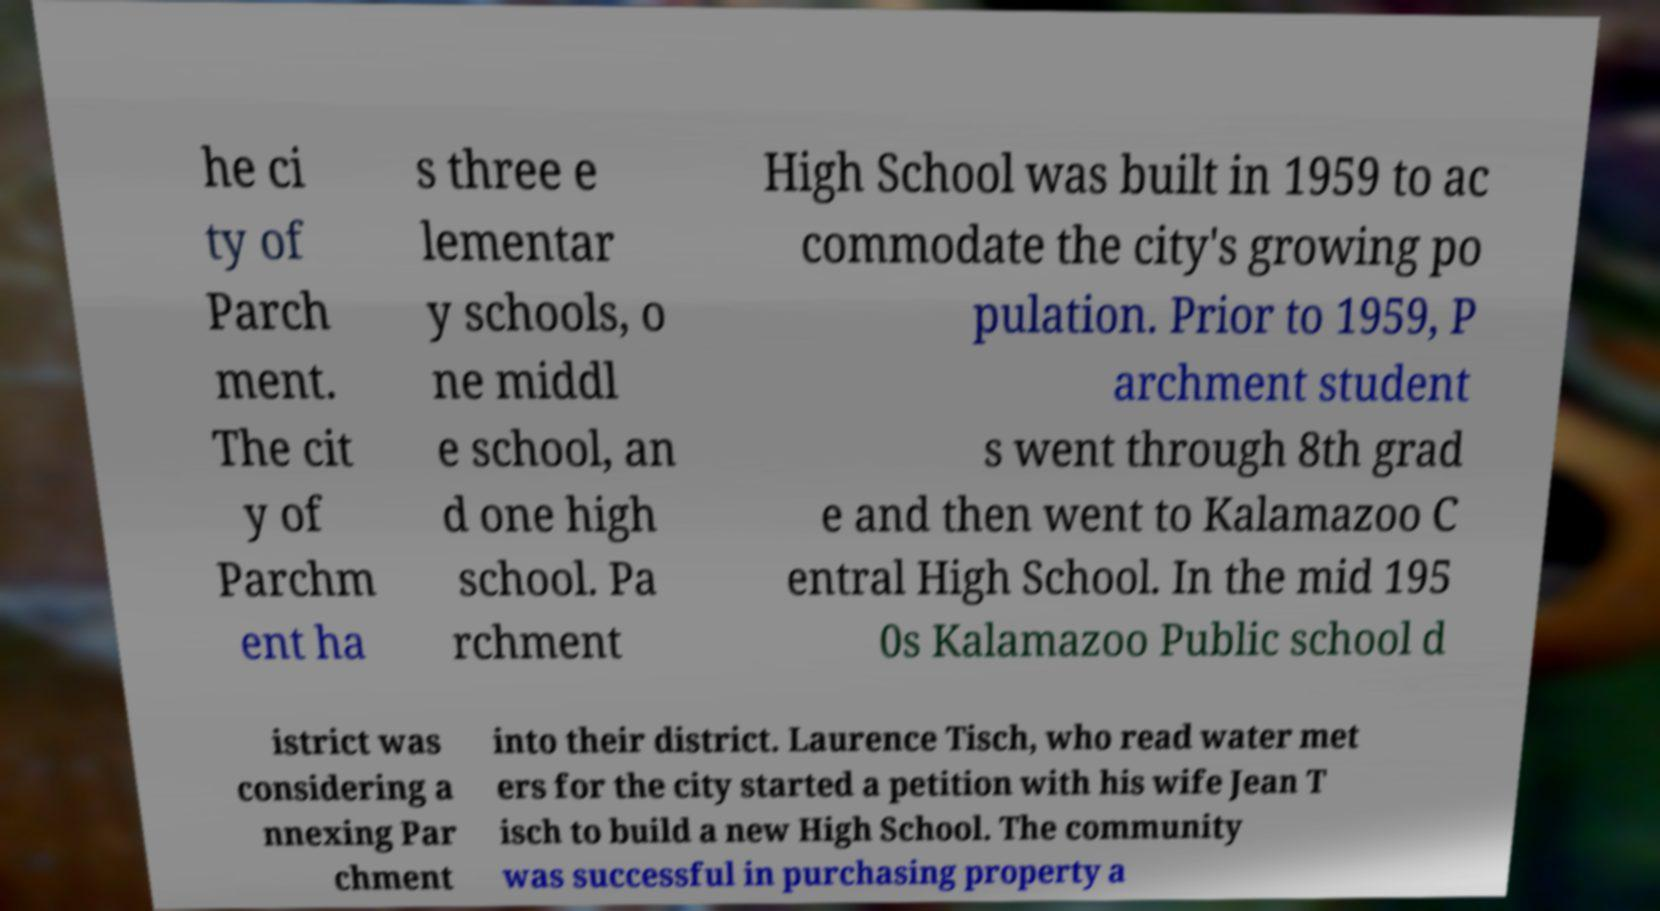Please identify and transcribe the text found in this image. he ci ty of Parch ment. The cit y of Parchm ent ha s three e lementar y schools, o ne middl e school, an d one high school. Pa rchment High School was built in 1959 to ac commodate the city's growing po pulation. Prior to 1959, P archment student s went through 8th grad e and then went to Kalamazoo C entral High School. In the mid 195 0s Kalamazoo Public school d istrict was considering a nnexing Par chment into their district. Laurence Tisch, who read water met ers for the city started a petition with his wife Jean T isch to build a new High School. The community was successful in purchasing property a 